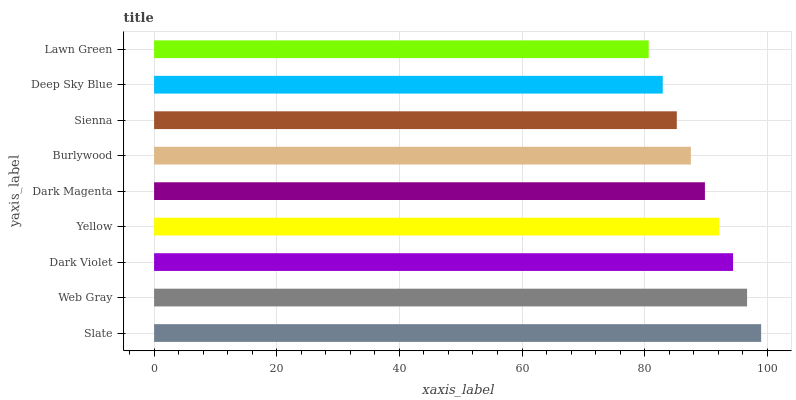Is Lawn Green the minimum?
Answer yes or no. Yes. Is Slate the maximum?
Answer yes or no. Yes. Is Web Gray the minimum?
Answer yes or no. No. Is Web Gray the maximum?
Answer yes or no. No. Is Slate greater than Web Gray?
Answer yes or no. Yes. Is Web Gray less than Slate?
Answer yes or no. Yes. Is Web Gray greater than Slate?
Answer yes or no. No. Is Slate less than Web Gray?
Answer yes or no. No. Is Dark Magenta the high median?
Answer yes or no. Yes. Is Dark Magenta the low median?
Answer yes or no. Yes. Is Slate the high median?
Answer yes or no. No. Is Slate the low median?
Answer yes or no. No. 